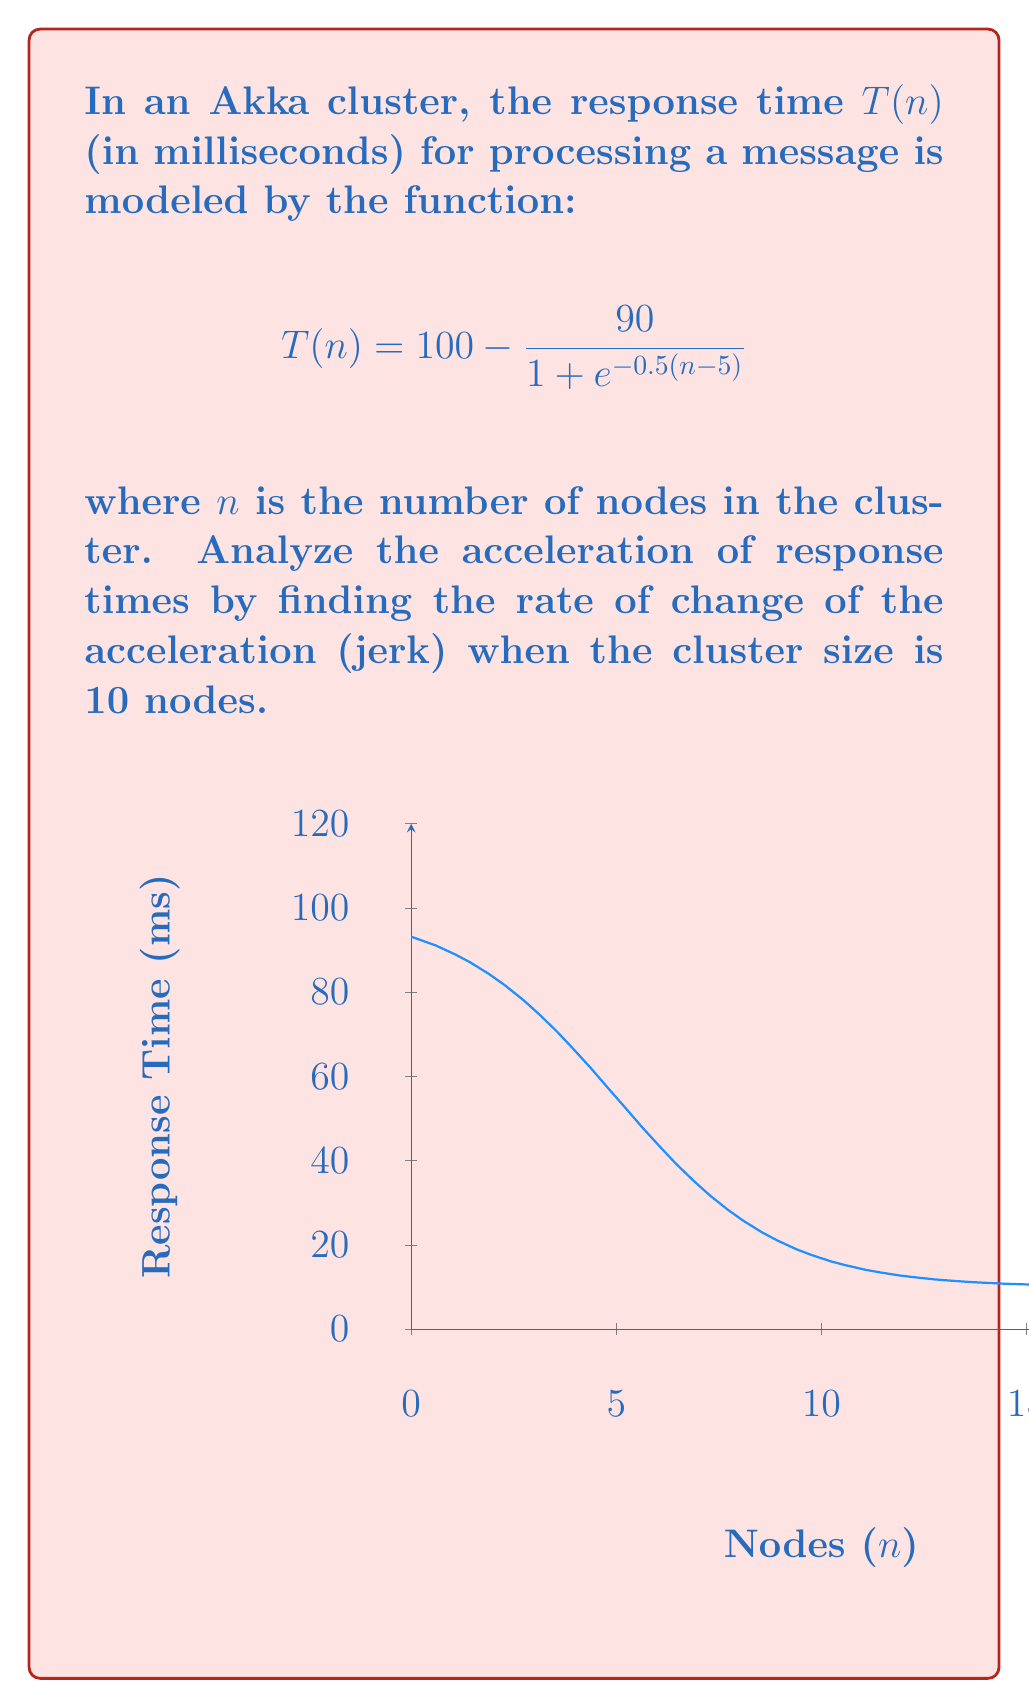Could you help me with this problem? To find the rate of change of acceleration (jerk), we need to calculate the third derivative of $T(n)$ with respect to $n$. Let's proceed step by step:

1) First, let's calculate $T'(n)$:
   $$T'(n) = \frac{45e^{-0.5(n-5)}}{(1 + e^{-0.5(n-5)})^2}$$

2) Now, let's calculate $T''(n)$ (acceleration):
   $$T''(n) = \frac{45e^{-0.5(n-5)}(e^{-0.5(n-5)} - 1)}{2(1 + e^{-0.5(n-5)})^3}$$

3) Finally, let's calculate $T'''(n)$ (jerk):
   $$T'''(n) = \frac{45e^{-0.5(n-5)}(1 - 4e^{-0.5(n-5)} + e^{-n+5})}{4(1 + e^{-0.5(n-5)})^4}$$

4) Now, we need to evaluate $T'''(n)$ at $n = 10$:
   $$T'''(10) = \frac{45e^{-2.5}(1 - 4e^{-2.5} + e^{-5})}{4(1 + e^{-2.5})^4}$$

5) Using a calculator or computer algebra system to evaluate this expression:
   $$T'''(10) \approx 0.0228$$

This value represents the rate of change of acceleration (jerk) when the Akka cluster has 10 nodes. The positive value indicates that the acceleration is increasing at this point, suggesting a continual improvement in response times as the cluster grows beyond 10 nodes.
Answer: $0.0228$ ms/node³ 